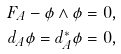Convert formula to latex. <formula><loc_0><loc_0><loc_500><loc_500>F _ { A } - \phi \wedge \phi & = 0 , \\ d _ { A } \phi = d _ { A } ^ { * } \phi & = 0 ,</formula> 